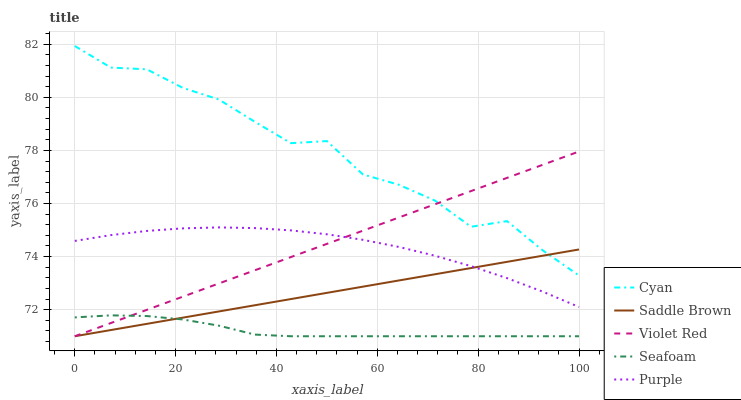Does Seafoam have the minimum area under the curve?
Answer yes or no. Yes. Does Cyan have the maximum area under the curve?
Answer yes or no. Yes. Does Violet Red have the minimum area under the curve?
Answer yes or no. No. Does Violet Red have the maximum area under the curve?
Answer yes or no. No. Is Saddle Brown the smoothest?
Answer yes or no. Yes. Is Cyan the roughest?
Answer yes or no. Yes. Is Violet Red the smoothest?
Answer yes or no. No. Is Violet Red the roughest?
Answer yes or no. No. Does Violet Red have the lowest value?
Answer yes or no. Yes. Does Cyan have the lowest value?
Answer yes or no. No. Does Cyan have the highest value?
Answer yes or no. Yes. Does Violet Red have the highest value?
Answer yes or no. No. Is Seafoam less than Cyan?
Answer yes or no. Yes. Is Cyan greater than Seafoam?
Answer yes or no. Yes. Does Seafoam intersect Saddle Brown?
Answer yes or no. Yes. Is Seafoam less than Saddle Brown?
Answer yes or no. No. Is Seafoam greater than Saddle Brown?
Answer yes or no. No. Does Seafoam intersect Cyan?
Answer yes or no. No. 